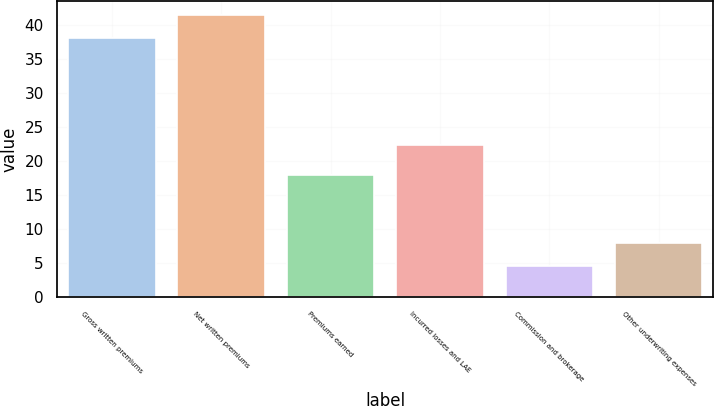Convert chart. <chart><loc_0><loc_0><loc_500><loc_500><bar_chart><fcel>Gross written premiums<fcel>Net written premiums<fcel>Premiums earned<fcel>Incurred losses and LAE<fcel>Commission and brokerage<fcel>Other underwriting expenses<nl><fcel>38.1<fcel>41.47<fcel>18<fcel>22.4<fcel>4.6<fcel>7.97<nl></chart> 